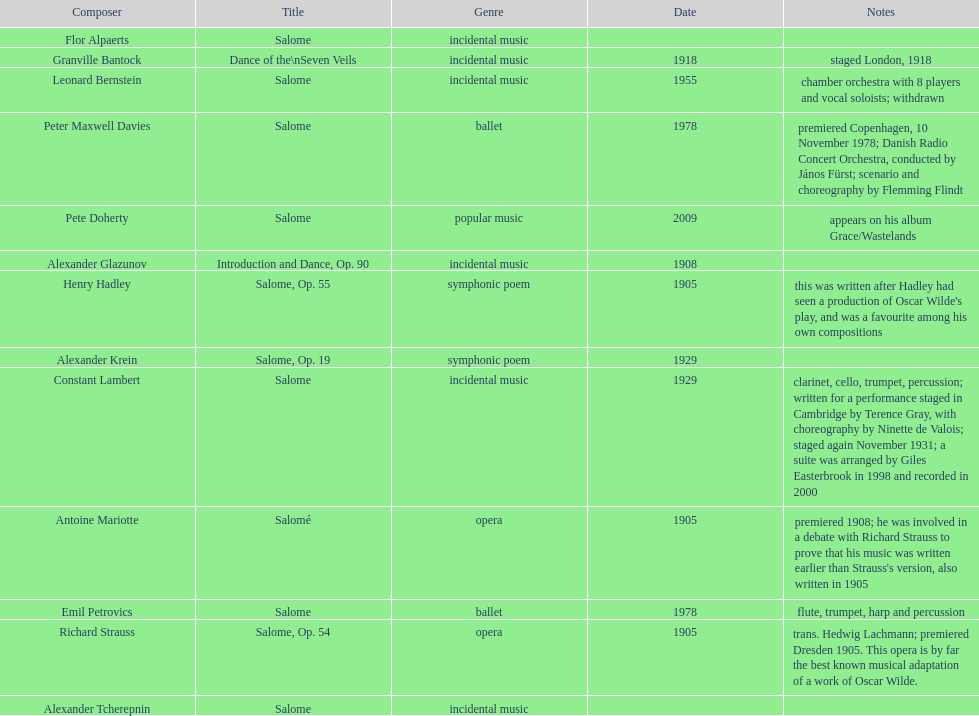What is the difference in years between granville bantock's and pete doherty's work? 91. 